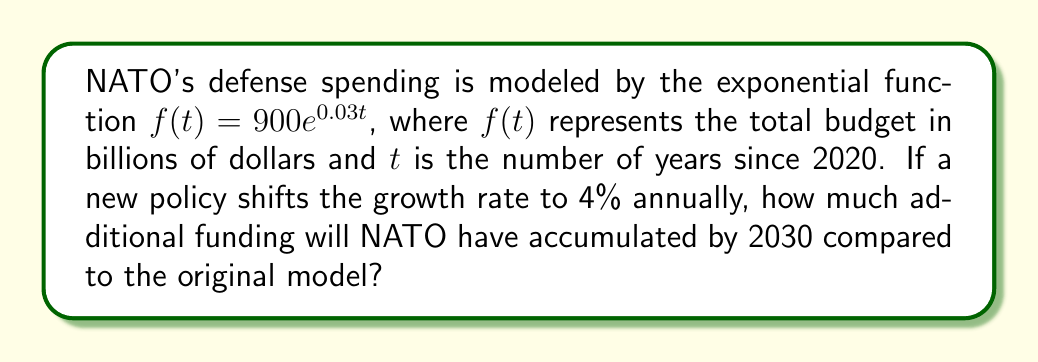Can you solve this math problem? To solve this problem, we need to follow these steps:

1) First, let's define the new function with the 4% growth rate:
   $g(t) = 900e^{0.04t}$

2) We need to calculate the difference between these two functions at t = 10 (representing 2030, 10 years after 2020):

   Difference = $g(10) - f(10)$

3) Calculate $f(10)$:
   $f(10) = 900e^{0.03(10)} = 900e^{0.3} \approx 1210.84$ billion dollars

4) Calculate $g(10)$:
   $g(10) = 900e^{0.04(10)} = 900e^{0.4} \approx 1339.43$ billion dollars

5) Calculate the difference:
   $1339.43 - 1210.84 = 128.59$ billion dollars

This represents the additional funding NATO will have accumulated by 2030 under the new growth rate compared to the original model.
Answer: NATO will have accumulated approximately $128.59 billion additional dollars by 2030 under the new 4% growth rate compared to the original 3% growth rate. 